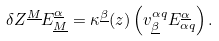<formula> <loc_0><loc_0><loc_500><loc_500>\delta Z ^ { \underline { M } } E _ { \underline { M } } ^ { \underline { \alpha } } = \kappa ^ { \underline { \beta } } ( z ) \left ( v _ { \underline { \beta } } ^ { \alpha q } E _ { \alpha q } ^ { \underline { \alpha } } \right ) .</formula> 